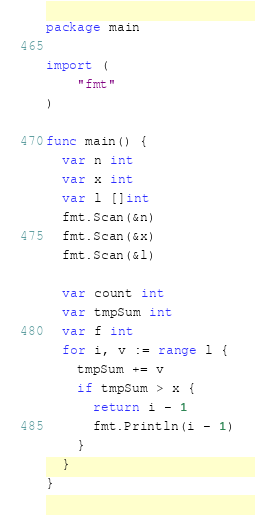<code> <loc_0><loc_0><loc_500><loc_500><_Go_>package main

import (
	"fmt"
)

func main() {
  var n int
  var x int
  var l []int
  fmt.Scan(&n)
  fmt.Scan(&x)
  fmt.Scan(&l)
  
  var count int
  var tmpSum int
  var f int
  for i, v := range l {
    tmpSum += v
    if tmpSum > x {
      return i - 1
      fmt.Println(i - 1)
    }
  }
}</code> 